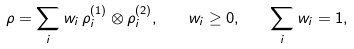<formula> <loc_0><loc_0><loc_500><loc_500>\rho = \sum _ { i } w _ { i } \, \rho _ { i } ^ { ( 1 ) } \otimes \rho _ { i } ^ { ( 2 ) } , \quad w _ { i } \geq 0 , \quad \sum _ { i } w _ { i } = 1 ,</formula> 